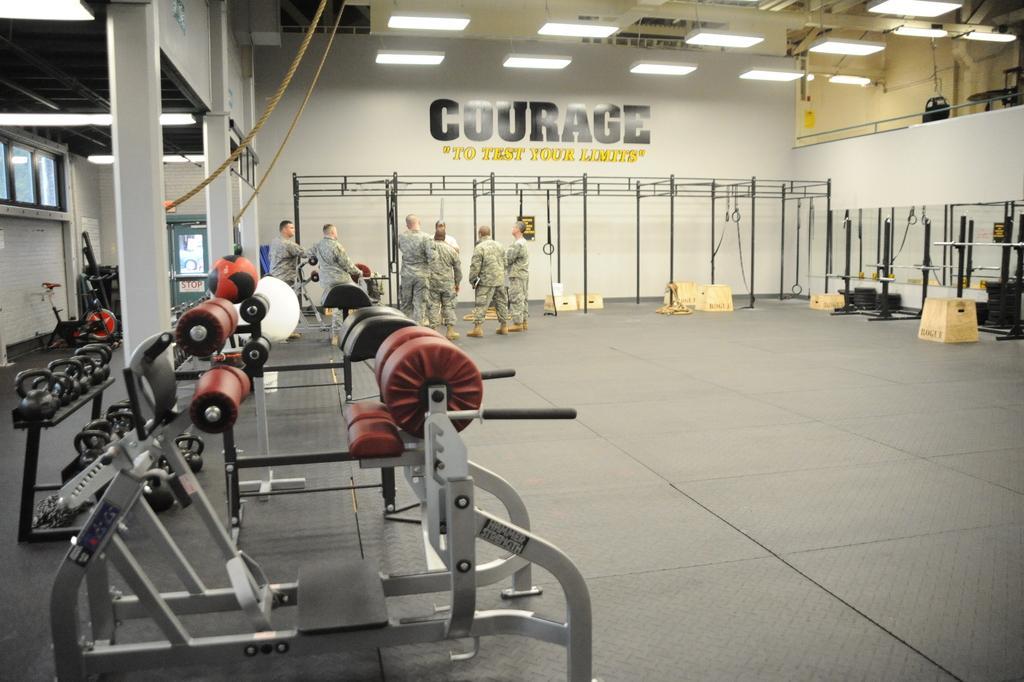How would you summarize this image in a sentence or two? In the image, it looks like the picture is captured inside a gym. There are different equipment and in the background there are a group of people standing on the floor and behind them there is a wall, on the wall there is some text. 